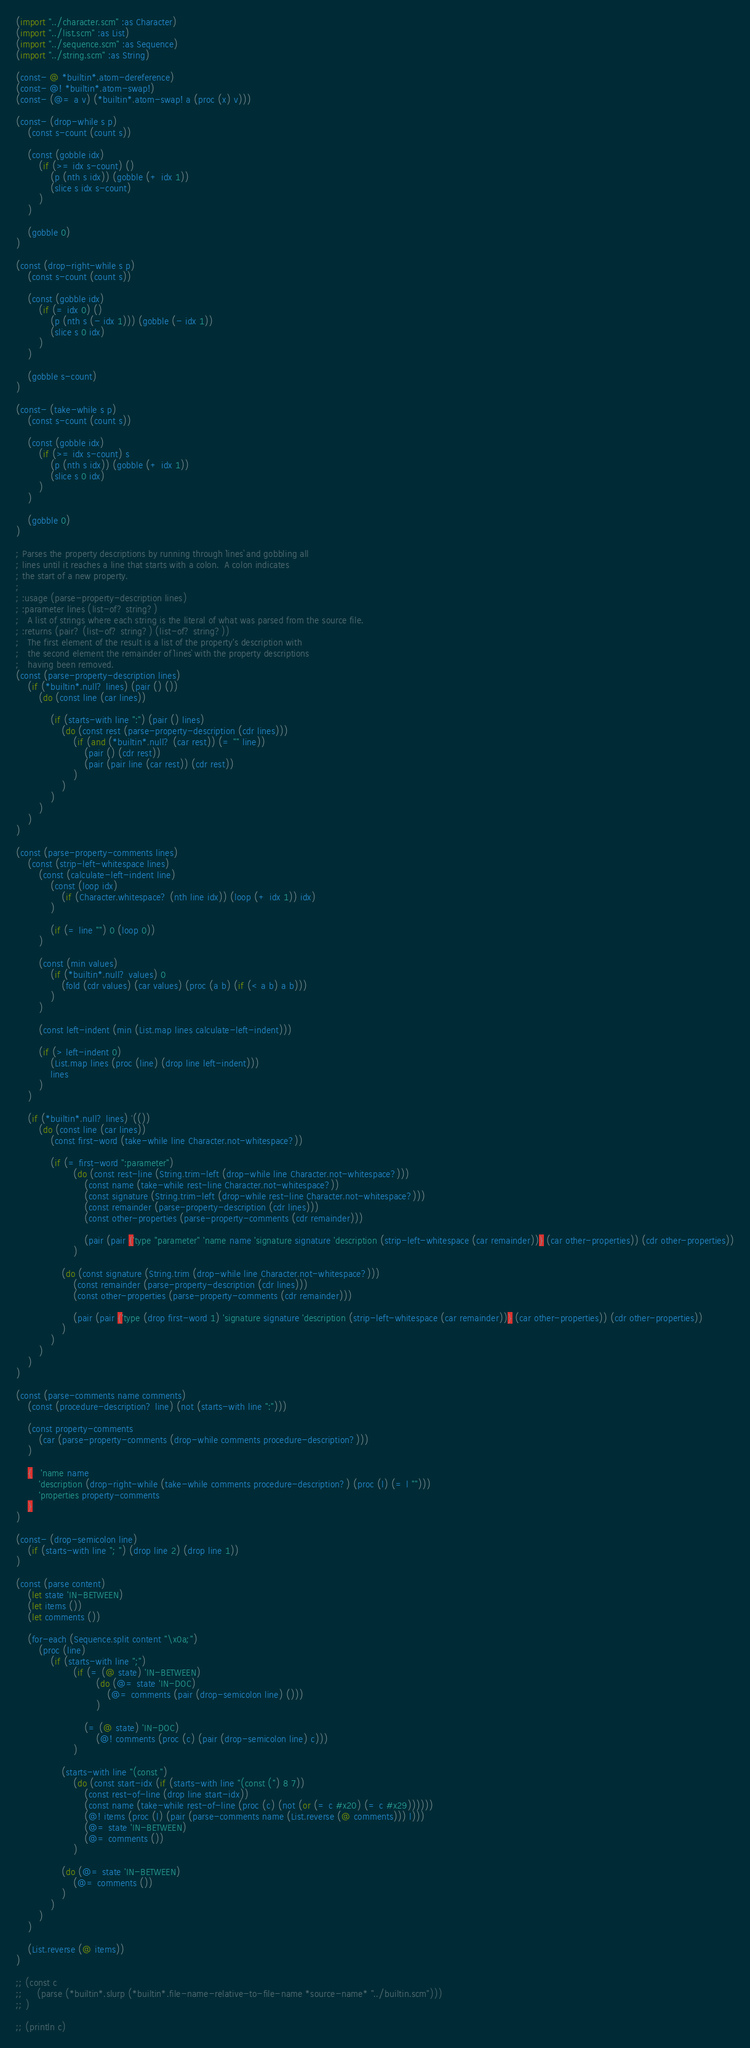<code> <loc_0><loc_0><loc_500><loc_500><_Scheme_>(import "../character.scm" :as Character)
(import "../list.scm" :as List)
(import "../sequence.scm" :as Sequence)
(import "../string.scm" :as String)

(const- @ *builtin*.atom-dereference)
(const- @! *builtin*.atom-swap!)
(const- (@= a v) (*builtin*.atom-swap! a (proc (x) v)))

(const- (drop-while s p)
    (const s-count (count s))

    (const (gobble idx)
        (if (>= idx s-count) ()
            (p (nth s idx)) (gobble (+ idx 1))
            (slice s idx s-count)
        )
    )

    (gobble 0)
)

(const (drop-right-while s p)
    (const s-count (count s))

    (const (gobble idx)
        (if (= idx 0) ()
            (p (nth s (- idx 1))) (gobble (- idx 1))
            (slice s 0 idx)
        )
    )

    (gobble s-count)
)

(const- (take-while s p)
    (const s-count (count s))

    (const (gobble idx)
        (if (>= idx s-count) s
            (p (nth s idx)) (gobble (+ idx 1))
            (slice s 0 idx)
        )
    )

    (gobble 0)
)

; Parses the property descriptions by running through `lines` and gobbling all 
; lines until it reaches a line that starts with a colon.  A colon indicates
; the start of a new property.
;
; :usage (parse-property-description lines)
; :parameter lines (list-of? string?)
;   A list of strings where each string is the literal of what was parsed from the source file.
; :returns (pair? (list-of? string?) (list-of? string?))
;   The first element of the result is a list of the property's description with 
;   the second element the remainder of `lines` with the property descriptions
;   having been removed.
(const (parse-property-description lines)
    (if (*builtin*.null? lines) (pair () ())
        (do (const line (car lines))

            (if (starts-with line ":") (pair () lines)
                (do (const rest (parse-property-description (cdr lines)))
                    (if (and (*builtin*.null? (car rest)) (= "" line))
                        (pair () (cdr rest))
                        (pair (pair line (car rest)) (cdr rest))
                    )
                )
            )
        )
    )
)

(const (parse-property-comments lines)
    (const (strip-left-whitespace lines)
        (const (calculate-left-indent line)
            (const (loop idx)
                (if (Character.whitespace? (nth line idx)) (loop (+ idx 1)) idx)
            )

            (if (= line "") 0 (loop 0))
        )

        (const (min values)
            (if (*builtin*.null? values) 0
                (fold (cdr values) (car values) (proc (a b) (if (< a b) a b)))
            )
        )

        (const left-indent (min (List.map lines calculate-left-indent)))

        (if (> left-indent 0)
            (List.map lines (proc (line) (drop line left-indent)))
            lines
        )
    )

    (if (*builtin*.null? lines) '(())
        (do (const line (car lines))
            (const first-word (take-while line Character.not-whitespace?))

            (if (= first-word ":parameter")
                    (do (const rest-line (String.trim-left (drop-while line Character.not-whitespace?)))
                        (const name (take-while rest-line Character.not-whitespace?))
                        (const signature (String.trim-left (drop-while rest-line Character.not-whitespace?)))
                        (const remainder (parse-property-description (cdr lines)))
                        (const other-properties (parse-property-comments (cdr remainder)))
                        
                        (pair (pair {'type "parameter" 'name name 'signature signature 'description (strip-left-whitespace (car remainder))} (car other-properties)) (cdr other-properties))
                    )

                (do (const signature (String.trim (drop-while line Character.not-whitespace?)))
                    (const remainder (parse-property-description (cdr lines)))
                    (const other-properties (parse-property-comments (cdr remainder)))

                    (pair (pair {'type (drop first-word 1) 'signature signature 'description (strip-left-whitespace (car remainder))} (car other-properties)) (cdr other-properties))
                )
            )
        )
    )
)

(const (parse-comments name comments)
    (const (procedure-description? line) (not (starts-with line ":")))

    (const property-comments
        (car (parse-property-comments (drop-while comments procedure-description?)))
    )

    {   'name name
        'description (drop-right-while (take-while comments procedure-description?) (proc (l) (= l "")))
        'properties property-comments
    }
)

(const- (drop-semicolon line)
    (if (starts-with line "; ") (drop line 2) (drop line 1))
)

(const (parse content)
    (let state 'IN-BETWEEN)
    (let items ())
    (let comments ())

    (for-each (Sequence.split content "\x0a;")
        (proc (line)
            (if (starts-with line ";")
                    (if (= (@ state) 'IN-BETWEEN)
                            (do (@= state 'IN-DOC)
                                (@= comments (pair (drop-semicolon line) ()))
                            )

                        (= (@ state) 'IN-DOC)
                            (@! comments (proc (c) (pair (drop-semicolon line) c)))
                    )

                (starts-with line "(const ")
                    (do (const start-idx (if (starts-with line "(const (") 8 7))
                        (const rest-of-line (drop line start-idx))
                        (const name (take-while rest-of-line (proc (c) (not (or (= c #x20) (= c #x29))))))   
                        (@! items (proc (l) (pair (parse-comments name (List.reverse (@ comments))) l)))
                        (@= state 'IN-BETWEEN)
                        (@= comments ())
                    )

                (do (@= state 'IN-BETWEEN)
                    (@= comments ())
                )
            )
        )
    )

    (List.reverse (@ items))
)

;; (const c
;;     (parse (*builtin*.slurp (*builtin*.file-name-relative-to-file-name *source-name* "../builtin.scm")))
;; )

;; (println c)
</code> 